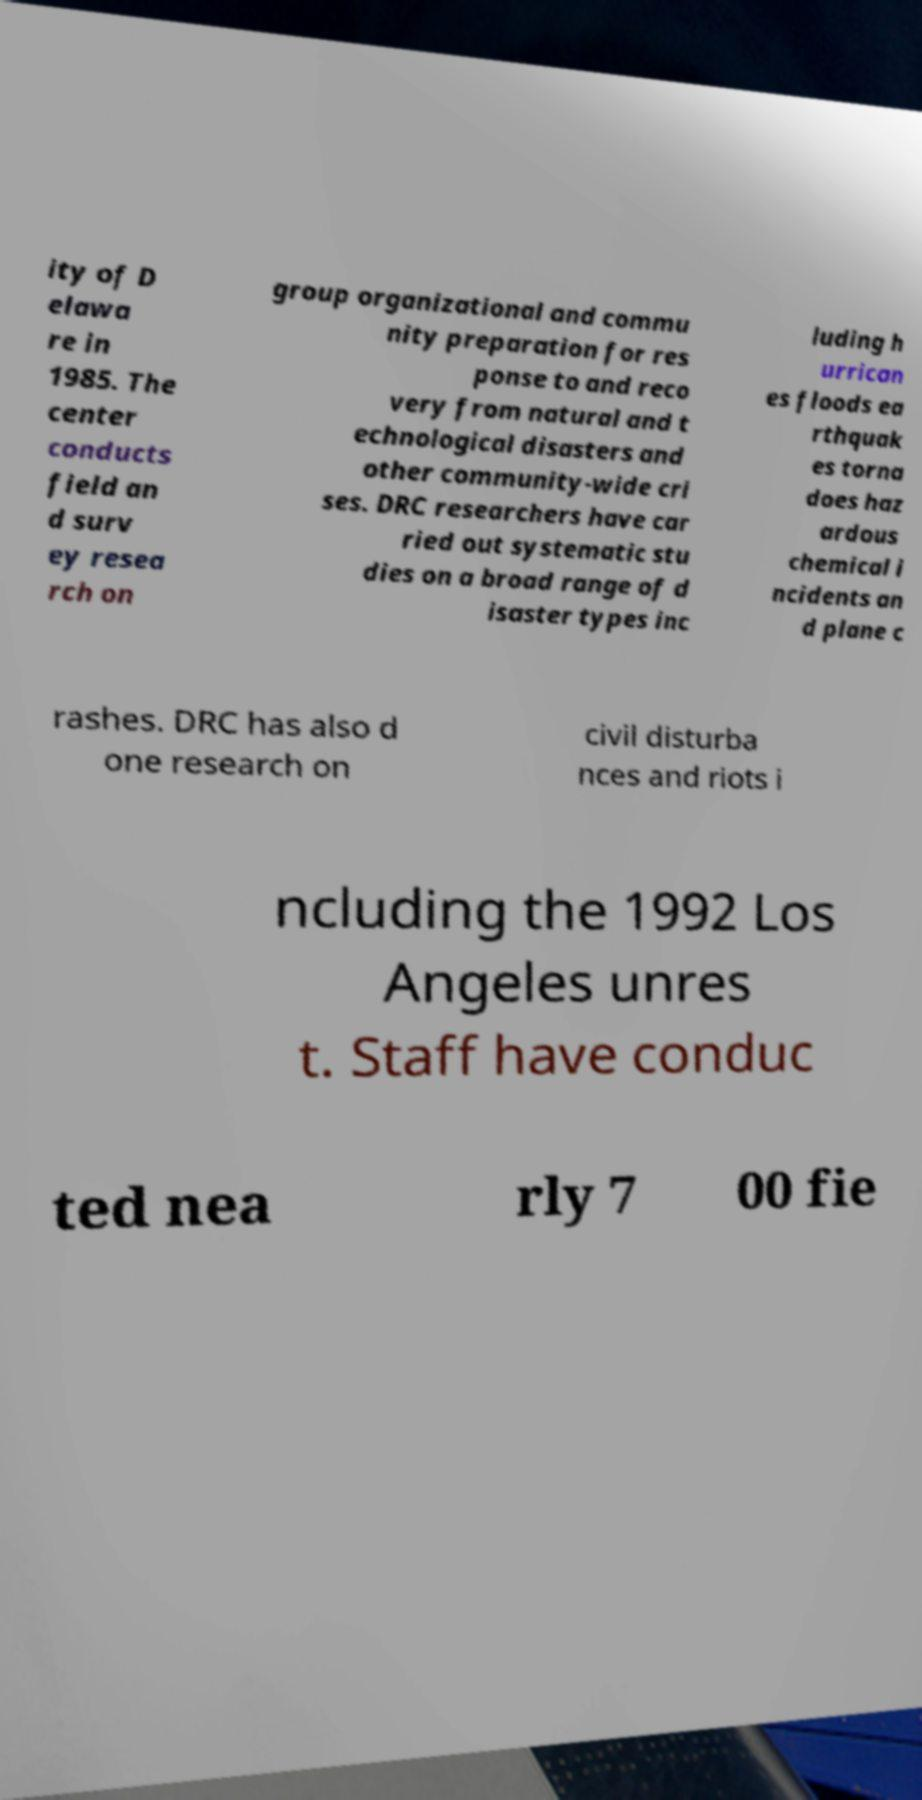For documentation purposes, I need the text within this image transcribed. Could you provide that? ity of D elawa re in 1985. The center conducts field an d surv ey resea rch on group organizational and commu nity preparation for res ponse to and reco very from natural and t echnological disasters and other community-wide cri ses. DRC researchers have car ried out systematic stu dies on a broad range of d isaster types inc luding h urrican es floods ea rthquak es torna does haz ardous chemical i ncidents an d plane c rashes. DRC has also d one research on civil disturba nces and riots i ncluding the 1992 Los Angeles unres t. Staff have conduc ted nea rly 7 00 fie 